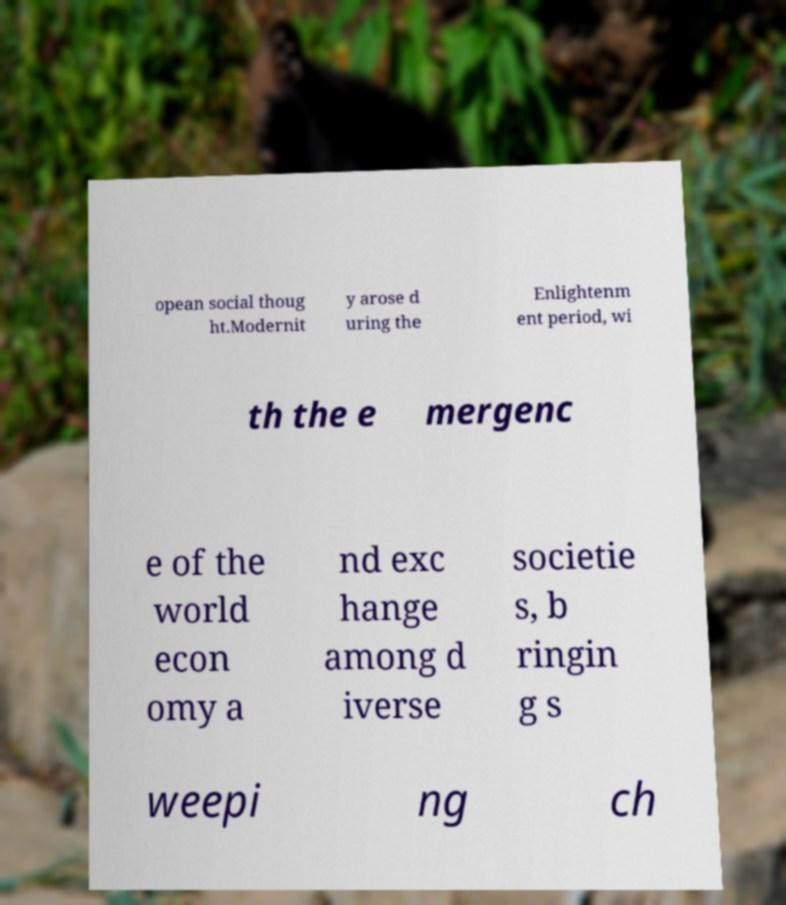Can you accurately transcribe the text from the provided image for me? opean social thoug ht.Modernit y arose d uring the Enlightenm ent period, wi th the e mergenc e of the world econ omy a nd exc hange among d iverse societie s, b ringin g s weepi ng ch 